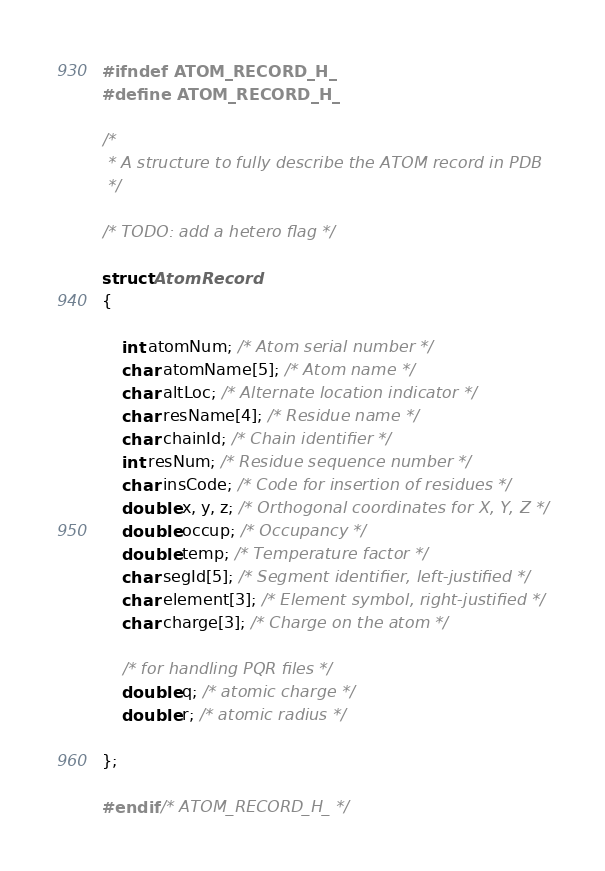<code> <loc_0><loc_0><loc_500><loc_500><_C_>
#ifndef ATOM_RECORD_H_
#define ATOM_RECORD_H_

/*
 * A structure to fully describe the ATOM record in PDB
 */

/* TODO: add a hetero flag */

struct AtomRecord
{

	int atomNum; /* Atom serial number */
	char atomName[5]; /* Atom name */
	char altLoc; /* Alternate location indicator */
	char resName[4]; /* Residue name */
	char chainId; /* Chain identifier */
	int resNum; /* Residue sequence number */
	char insCode; /* Code for insertion of residues */
	double x, y, z; /* Orthogonal coordinates for X, Y, Z */
	double occup; /* Occupancy */
	double temp; /* Temperature factor */
	char segId[5]; /* Segment identifier, left-justified */
	char element[3]; /* Element symbol, right-justified */
	char charge[3]; /* Charge on the atom */

	/* for handling PQR files */
	double q; /* atomic charge */
	double r; /* atomic radius */

};

#endif /* ATOM_RECORD_H_ */
</code> 